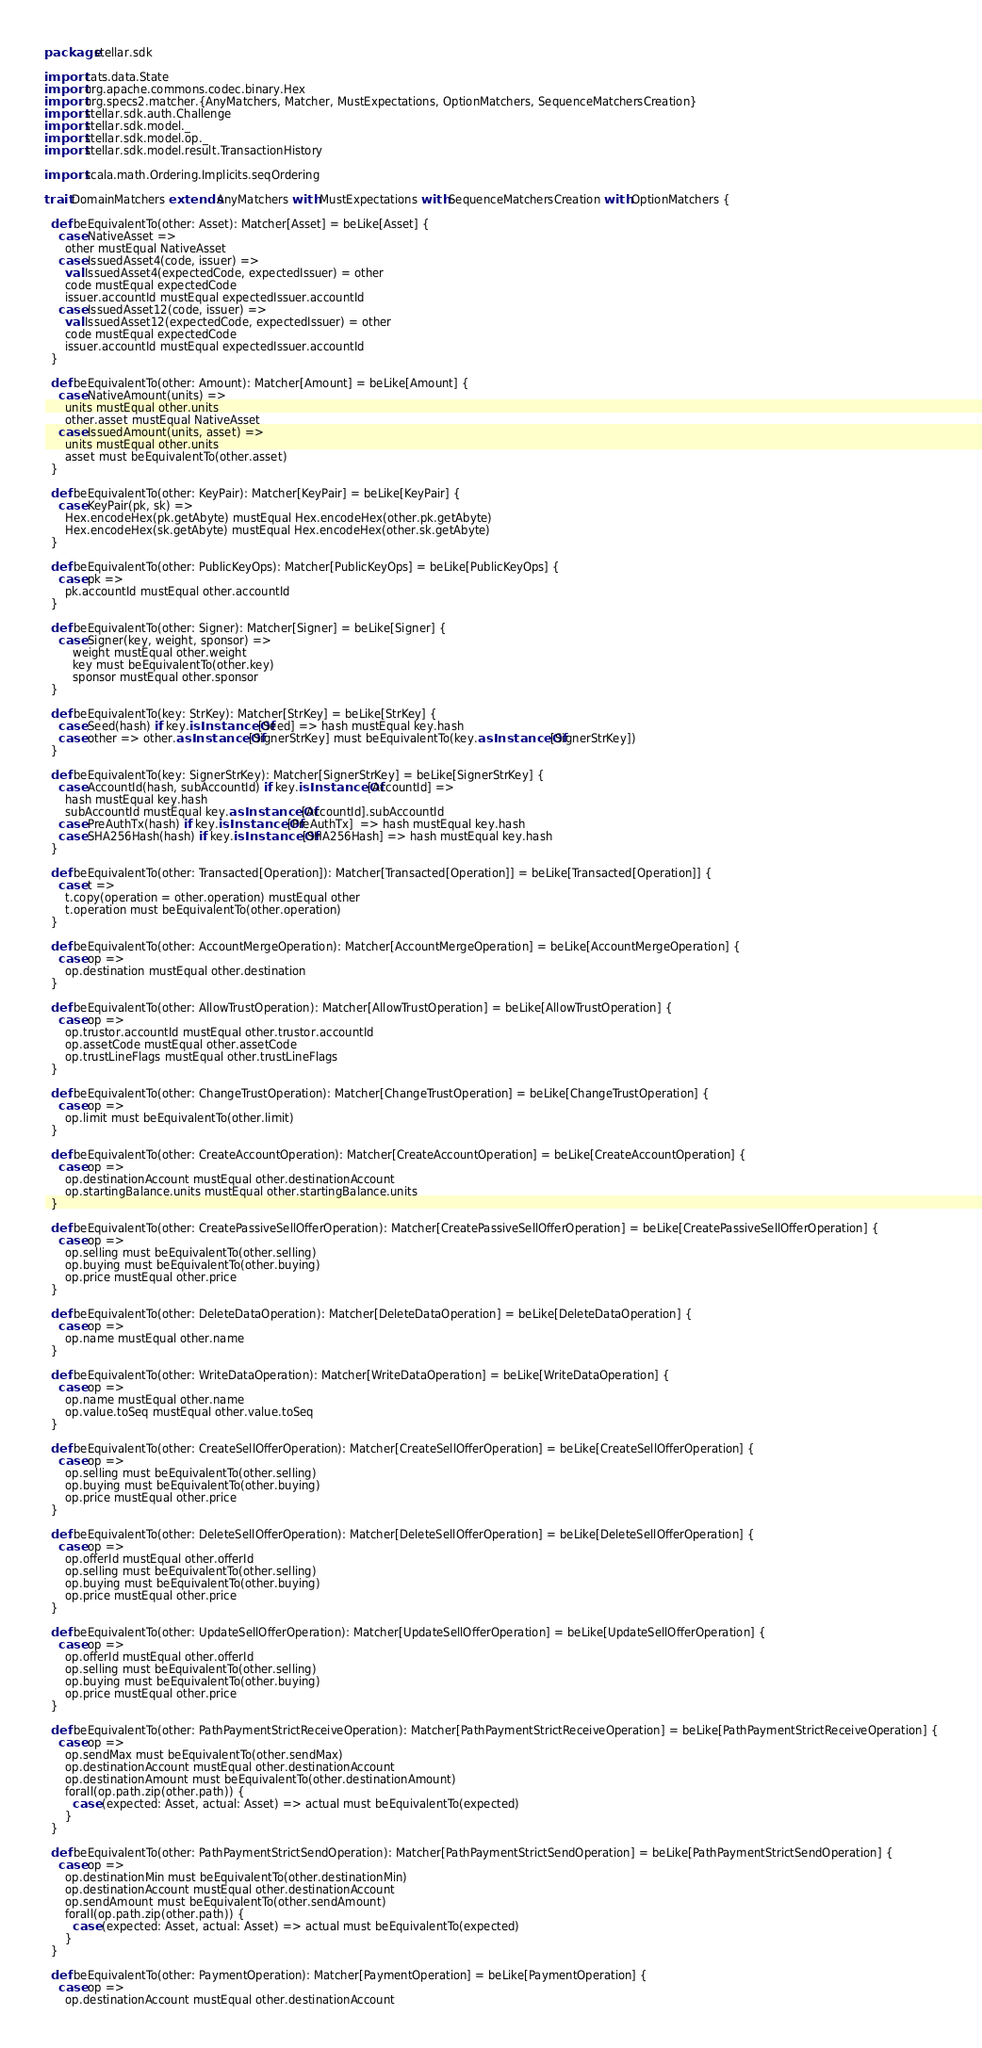Convert code to text. <code><loc_0><loc_0><loc_500><loc_500><_Scala_>package stellar.sdk

import cats.data.State
import org.apache.commons.codec.binary.Hex
import org.specs2.matcher.{AnyMatchers, Matcher, MustExpectations, OptionMatchers, SequenceMatchersCreation}
import stellar.sdk.auth.Challenge
import stellar.sdk.model._
import stellar.sdk.model.op._
import stellar.sdk.model.result.TransactionHistory

import scala.math.Ordering.Implicits.seqOrdering

trait DomainMatchers extends AnyMatchers with MustExpectations with SequenceMatchersCreation with OptionMatchers {

  def beEquivalentTo(other: Asset): Matcher[Asset] = beLike[Asset] {
    case NativeAsset =>
      other mustEqual NativeAsset
    case IssuedAsset4(code, issuer) =>
      val IssuedAsset4(expectedCode, expectedIssuer) = other
      code mustEqual expectedCode
      issuer.accountId mustEqual expectedIssuer.accountId
    case IssuedAsset12(code, issuer) =>
      val IssuedAsset12(expectedCode, expectedIssuer) = other
      code mustEqual expectedCode
      issuer.accountId mustEqual expectedIssuer.accountId
  }

  def beEquivalentTo(other: Amount): Matcher[Amount] = beLike[Amount] {
    case NativeAmount(units) =>
      units mustEqual other.units
      other.asset mustEqual NativeAsset
    case IssuedAmount(units, asset) =>
      units mustEqual other.units
      asset must beEquivalentTo(other.asset)
  }

  def beEquivalentTo(other: KeyPair): Matcher[KeyPair] = beLike[KeyPair] {
    case KeyPair(pk, sk) =>
      Hex.encodeHex(pk.getAbyte) mustEqual Hex.encodeHex(other.pk.getAbyte)
      Hex.encodeHex(sk.getAbyte) mustEqual Hex.encodeHex(other.sk.getAbyte)
  }

  def beEquivalentTo(other: PublicKeyOps): Matcher[PublicKeyOps] = beLike[PublicKeyOps] {
    case pk =>
      pk.accountId mustEqual other.accountId
  }

  def beEquivalentTo(other: Signer): Matcher[Signer] = beLike[Signer] {
    case Signer(key, weight, sponsor) =>
        weight mustEqual other.weight
        key must beEquivalentTo(other.key)
        sponsor mustEqual other.sponsor
  }

  def beEquivalentTo(key: StrKey): Matcher[StrKey] = beLike[StrKey] {
    case Seed(hash) if key.isInstanceOf[Seed] => hash mustEqual key.hash
    case other => other.asInstanceOf[SignerStrKey] must beEquivalentTo(key.asInstanceOf[SignerStrKey])
  }

  def beEquivalentTo(key: SignerStrKey): Matcher[SignerStrKey] = beLike[SignerStrKey] {
    case AccountId(hash, subAccountId) if key.isInstanceOf[AccountId] =>
      hash mustEqual key.hash
      subAccountId mustEqual key.asInstanceOf[AccountId].subAccountId
    case PreAuthTx(hash) if key.isInstanceOf[PreAuthTx]  => hash mustEqual key.hash
    case SHA256Hash(hash) if key.isInstanceOf[SHA256Hash] => hash mustEqual key.hash
  }

  def beEquivalentTo(other: Transacted[Operation]): Matcher[Transacted[Operation]] = beLike[Transacted[Operation]] {
    case t =>
      t.copy(operation = other.operation) mustEqual other
      t.operation must beEquivalentTo(other.operation)
  }

  def beEquivalentTo(other: AccountMergeOperation): Matcher[AccountMergeOperation] = beLike[AccountMergeOperation] {
    case op =>
      op.destination mustEqual other.destination
  }

  def beEquivalentTo(other: AllowTrustOperation): Matcher[AllowTrustOperation] = beLike[AllowTrustOperation] {
    case op =>
      op.trustor.accountId mustEqual other.trustor.accountId
      op.assetCode mustEqual other.assetCode
      op.trustLineFlags mustEqual other.trustLineFlags
  }

  def beEquivalentTo(other: ChangeTrustOperation): Matcher[ChangeTrustOperation] = beLike[ChangeTrustOperation] {
    case op =>
      op.limit must beEquivalentTo(other.limit)
  }

  def beEquivalentTo(other: CreateAccountOperation): Matcher[CreateAccountOperation] = beLike[CreateAccountOperation] {
    case op =>
      op.destinationAccount mustEqual other.destinationAccount
      op.startingBalance.units mustEqual other.startingBalance.units
  }

  def beEquivalentTo(other: CreatePassiveSellOfferOperation): Matcher[CreatePassiveSellOfferOperation] = beLike[CreatePassiveSellOfferOperation] {
    case op =>
      op.selling must beEquivalentTo(other.selling)
      op.buying must beEquivalentTo(other.buying)
      op.price mustEqual other.price
  }

  def beEquivalentTo(other: DeleteDataOperation): Matcher[DeleteDataOperation] = beLike[DeleteDataOperation] {
    case op =>
      op.name mustEqual other.name
  }

  def beEquivalentTo(other: WriteDataOperation): Matcher[WriteDataOperation] = beLike[WriteDataOperation] {
    case op =>
      op.name mustEqual other.name
      op.value.toSeq mustEqual other.value.toSeq
  }

  def beEquivalentTo(other: CreateSellOfferOperation): Matcher[CreateSellOfferOperation] = beLike[CreateSellOfferOperation] {
    case op =>
      op.selling must beEquivalentTo(other.selling)
      op.buying must beEquivalentTo(other.buying)
      op.price mustEqual other.price
  }

  def beEquivalentTo(other: DeleteSellOfferOperation): Matcher[DeleteSellOfferOperation] = beLike[DeleteSellOfferOperation] {
    case op =>
      op.offerId mustEqual other.offerId
      op.selling must beEquivalentTo(other.selling)
      op.buying must beEquivalentTo(other.buying)
      op.price mustEqual other.price
  }

  def beEquivalentTo(other: UpdateSellOfferOperation): Matcher[UpdateSellOfferOperation] = beLike[UpdateSellOfferOperation] {
    case op =>
      op.offerId mustEqual other.offerId
      op.selling must beEquivalentTo(other.selling)
      op.buying must beEquivalentTo(other.buying)
      op.price mustEqual other.price
  }

  def beEquivalentTo(other: PathPaymentStrictReceiveOperation): Matcher[PathPaymentStrictReceiveOperation] = beLike[PathPaymentStrictReceiveOperation] {
    case op =>
      op.sendMax must beEquivalentTo(other.sendMax)
      op.destinationAccount mustEqual other.destinationAccount
      op.destinationAmount must beEquivalentTo(other.destinationAmount)
      forall(op.path.zip(other.path)) {
        case (expected: Asset, actual: Asset) => actual must beEquivalentTo(expected)
      }
  }

  def beEquivalentTo(other: PathPaymentStrictSendOperation): Matcher[PathPaymentStrictSendOperation] = beLike[PathPaymentStrictSendOperation] {
    case op =>
      op.destinationMin must beEquivalentTo(other.destinationMin)
      op.destinationAccount mustEqual other.destinationAccount
      op.sendAmount must beEquivalentTo(other.sendAmount)
      forall(op.path.zip(other.path)) {
        case (expected: Asset, actual: Asset) => actual must beEquivalentTo(expected)
      }
  }

  def beEquivalentTo(other: PaymentOperation): Matcher[PaymentOperation] = beLike[PaymentOperation] {
    case op =>
      op.destinationAccount mustEqual other.destinationAccount</code> 